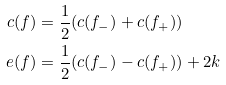<formula> <loc_0><loc_0><loc_500><loc_500>c ( f ) & = \frac { 1 } { 2 } ( c ( f _ { - } ) + c ( f _ { + } ) ) \\ e ( f ) & = \frac { 1 } { 2 } ( c ( f _ { - } ) - c ( f _ { + } ) ) + 2 k</formula> 